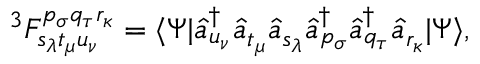Convert formula to latex. <formula><loc_0><loc_0><loc_500><loc_500>^ { 3 } F _ { s _ { \lambda } t _ { \mu } u _ { \nu } } ^ { p _ { \sigma } q _ { \tau } r _ { \kappa } } = \langle \Psi | \hat { a } _ { u _ { \nu } } ^ { \dagger } \hat { a } _ { t _ { \mu } } \hat { a } _ { s _ { \lambda } } \hat { a } _ { p _ { \sigma } } ^ { \dagger } \hat { a } _ { q _ { \tau } } ^ { \dagger } \hat { a } _ { r _ { \kappa } } | \Psi \rangle ,</formula> 